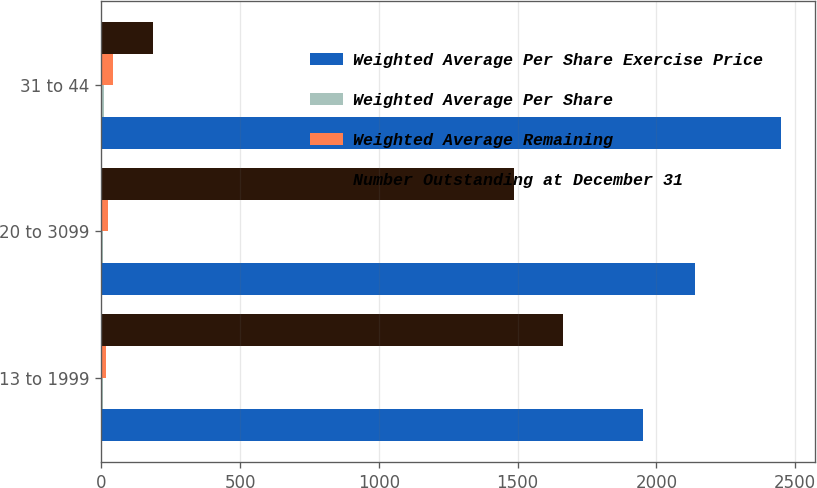Convert chart. <chart><loc_0><loc_0><loc_500><loc_500><stacked_bar_chart><ecel><fcel>13 to 1999<fcel>20 to 3099<fcel>31 to 44<nl><fcel>Weighted Average Per Share Exercise Price<fcel>1951<fcel>2139<fcel>2449<nl><fcel>Weighted Average Per Share<fcel>4.3<fcel>6<fcel>9.2<nl><fcel>Weighted Average Remaining<fcel>17<fcel>23<fcel>41<nl><fcel>Number Outstanding at December 31<fcel>1665<fcel>1487<fcel>186<nl></chart> 